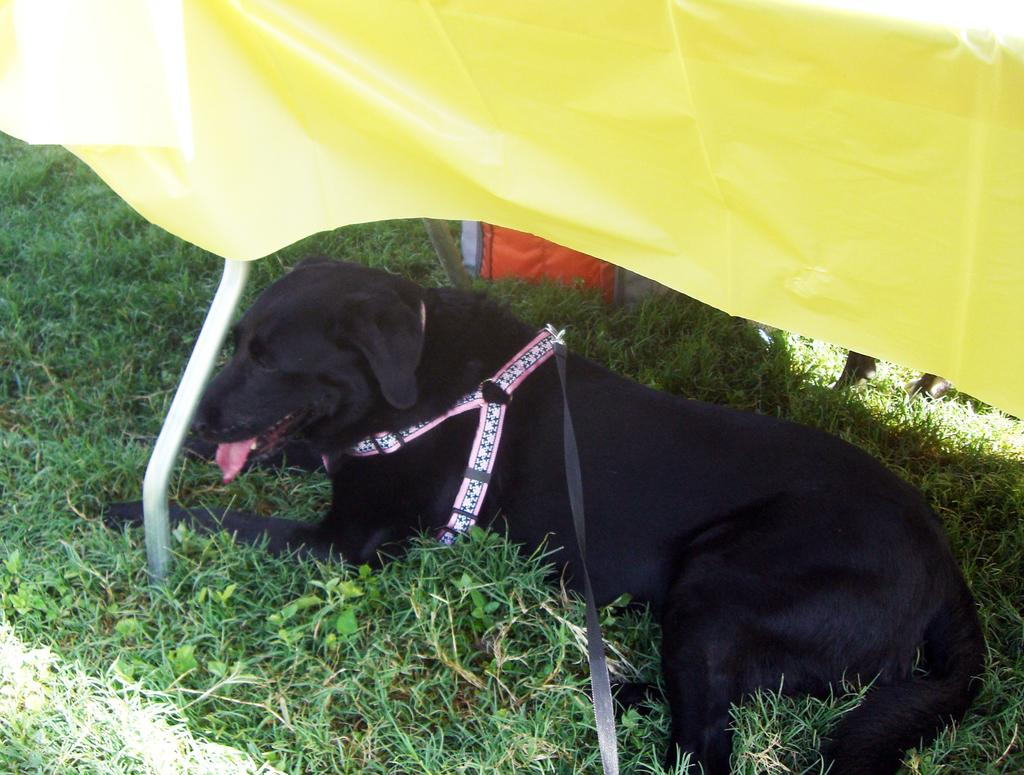What type of animal is in the image? There is a black dog in the image. What is the dog doing in the image? The dog is sitting on the ground. Is the dog wearing any accessories in the image? Yes, the dog is wearing a belt. What type of terrain is visible in the image? There is grass visible in the image. What color is the object next to the dog? There is a yellow object in the image. Can you describe any other objects present in the image? There are other objects present in the image, but their specific details are not mentioned in the provided facts. What type of ear is the dog using to listen to music in the image? There is no indication in the image that the dog is using an ear to listen to music, nor is there any visible ear on the dog. 